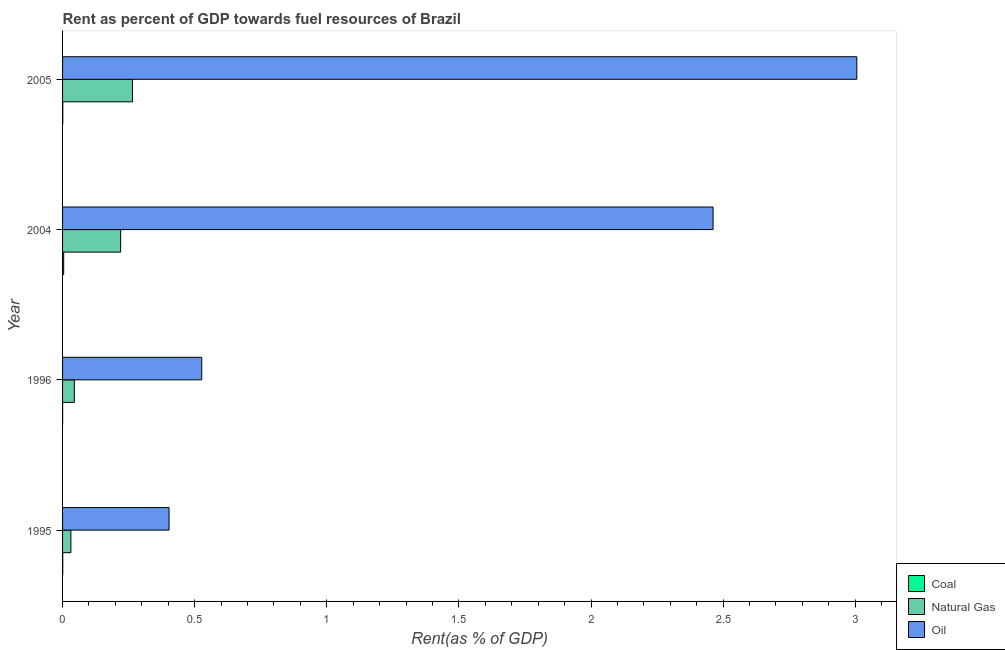Are the number of bars per tick equal to the number of legend labels?
Offer a very short reply. Yes. Are the number of bars on each tick of the Y-axis equal?
Keep it short and to the point. Yes. How many bars are there on the 2nd tick from the top?
Keep it short and to the point. 3. How many bars are there on the 2nd tick from the bottom?
Give a very brief answer. 3. What is the label of the 2nd group of bars from the top?
Offer a terse response. 2004. In how many cases, is the number of bars for a given year not equal to the number of legend labels?
Give a very brief answer. 0. What is the rent towards oil in 1995?
Offer a very short reply. 0.4. Across all years, what is the maximum rent towards natural gas?
Provide a short and direct response. 0.26. Across all years, what is the minimum rent towards coal?
Offer a terse response. 0. What is the total rent towards natural gas in the graph?
Offer a very short reply. 0.56. What is the difference between the rent towards oil in 1995 and that in 2005?
Your answer should be compact. -2.6. What is the difference between the rent towards oil in 1996 and the rent towards coal in 2005?
Provide a succinct answer. 0.53. What is the average rent towards natural gas per year?
Offer a very short reply. 0.14. In the year 1996, what is the difference between the rent towards natural gas and rent towards coal?
Your response must be concise. 0.04. What is the ratio of the rent towards coal in 1996 to that in 2004?
Keep it short and to the point. 0.06. Is the rent towards coal in 2004 less than that in 2005?
Ensure brevity in your answer.  No. What is the difference between the highest and the second highest rent towards coal?
Your answer should be compact. 0. Is the sum of the rent towards oil in 1995 and 1996 greater than the maximum rent towards natural gas across all years?
Provide a short and direct response. Yes. What does the 2nd bar from the top in 1995 represents?
Your response must be concise. Natural Gas. What does the 3rd bar from the bottom in 2004 represents?
Give a very brief answer. Oil. How many bars are there?
Your answer should be very brief. 12. Are all the bars in the graph horizontal?
Offer a very short reply. Yes. How many years are there in the graph?
Offer a very short reply. 4. What is the difference between two consecutive major ticks on the X-axis?
Offer a terse response. 0.5. Does the graph contain grids?
Give a very brief answer. No. Where does the legend appear in the graph?
Provide a succinct answer. Bottom right. How many legend labels are there?
Ensure brevity in your answer.  3. How are the legend labels stacked?
Provide a succinct answer. Vertical. What is the title of the graph?
Keep it short and to the point. Rent as percent of GDP towards fuel resources of Brazil. What is the label or title of the X-axis?
Ensure brevity in your answer.  Rent(as % of GDP). What is the Rent(as % of GDP) in Coal in 1995?
Provide a succinct answer. 0. What is the Rent(as % of GDP) of Natural Gas in 1995?
Keep it short and to the point. 0.03. What is the Rent(as % of GDP) of Oil in 1995?
Your answer should be very brief. 0.4. What is the Rent(as % of GDP) in Coal in 1996?
Offer a terse response. 0. What is the Rent(as % of GDP) in Natural Gas in 1996?
Offer a very short reply. 0.04. What is the Rent(as % of GDP) of Oil in 1996?
Your answer should be compact. 0.53. What is the Rent(as % of GDP) in Coal in 2004?
Keep it short and to the point. 0. What is the Rent(as % of GDP) in Natural Gas in 2004?
Your response must be concise. 0.22. What is the Rent(as % of GDP) of Oil in 2004?
Offer a very short reply. 2.46. What is the Rent(as % of GDP) in Coal in 2005?
Give a very brief answer. 0. What is the Rent(as % of GDP) in Natural Gas in 2005?
Your response must be concise. 0.26. What is the Rent(as % of GDP) of Oil in 2005?
Provide a short and direct response. 3.01. Across all years, what is the maximum Rent(as % of GDP) of Coal?
Make the answer very short. 0. Across all years, what is the maximum Rent(as % of GDP) of Natural Gas?
Offer a terse response. 0.26. Across all years, what is the maximum Rent(as % of GDP) in Oil?
Ensure brevity in your answer.  3.01. Across all years, what is the minimum Rent(as % of GDP) in Coal?
Give a very brief answer. 0. Across all years, what is the minimum Rent(as % of GDP) in Natural Gas?
Your answer should be very brief. 0.03. Across all years, what is the minimum Rent(as % of GDP) of Oil?
Give a very brief answer. 0.4. What is the total Rent(as % of GDP) in Coal in the graph?
Offer a terse response. 0.01. What is the total Rent(as % of GDP) of Natural Gas in the graph?
Offer a very short reply. 0.56. What is the total Rent(as % of GDP) of Oil in the graph?
Give a very brief answer. 6.4. What is the difference between the Rent(as % of GDP) in Natural Gas in 1995 and that in 1996?
Give a very brief answer. -0.01. What is the difference between the Rent(as % of GDP) in Oil in 1995 and that in 1996?
Provide a short and direct response. -0.12. What is the difference between the Rent(as % of GDP) of Coal in 1995 and that in 2004?
Your response must be concise. -0. What is the difference between the Rent(as % of GDP) of Natural Gas in 1995 and that in 2004?
Your answer should be compact. -0.19. What is the difference between the Rent(as % of GDP) in Oil in 1995 and that in 2004?
Your answer should be compact. -2.06. What is the difference between the Rent(as % of GDP) of Coal in 1995 and that in 2005?
Provide a succinct answer. -0. What is the difference between the Rent(as % of GDP) in Natural Gas in 1995 and that in 2005?
Provide a short and direct response. -0.23. What is the difference between the Rent(as % of GDP) in Oil in 1995 and that in 2005?
Keep it short and to the point. -2.6. What is the difference between the Rent(as % of GDP) of Coal in 1996 and that in 2004?
Keep it short and to the point. -0. What is the difference between the Rent(as % of GDP) of Natural Gas in 1996 and that in 2004?
Ensure brevity in your answer.  -0.18. What is the difference between the Rent(as % of GDP) in Oil in 1996 and that in 2004?
Your answer should be very brief. -1.94. What is the difference between the Rent(as % of GDP) of Coal in 1996 and that in 2005?
Provide a short and direct response. -0. What is the difference between the Rent(as % of GDP) in Natural Gas in 1996 and that in 2005?
Provide a short and direct response. -0.22. What is the difference between the Rent(as % of GDP) of Oil in 1996 and that in 2005?
Your answer should be compact. -2.48. What is the difference between the Rent(as % of GDP) in Coal in 2004 and that in 2005?
Your answer should be compact. 0. What is the difference between the Rent(as % of GDP) of Natural Gas in 2004 and that in 2005?
Give a very brief answer. -0.04. What is the difference between the Rent(as % of GDP) of Oil in 2004 and that in 2005?
Offer a terse response. -0.54. What is the difference between the Rent(as % of GDP) of Coal in 1995 and the Rent(as % of GDP) of Natural Gas in 1996?
Offer a very short reply. -0.04. What is the difference between the Rent(as % of GDP) in Coal in 1995 and the Rent(as % of GDP) in Oil in 1996?
Provide a short and direct response. -0.53. What is the difference between the Rent(as % of GDP) of Natural Gas in 1995 and the Rent(as % of GDP) of Oil in 1996?
Make the answer very short. -0.5. What is the difference between the Rent(as % of GDP) in Coal in 1995 and the Rent(as % of GDP) in Natural Gas in 2004?
Your answer should be compact. -0.22. What is the difference between the Rent(as % of GDP) in Coal in 1995 and the Rent(as % of GDP) in Oil in 2004?
Ensure brevity in your answer.  -2.46. What is the difference between the Rent(as % of GDP) of Natural Gas in 1995 and the Rent(as % of GDP) of Oil in 2004?
Give a very brief answer. -2.43. What is the difference between the Rent(as % of GDP) of Coal in 1995 and the Rent(as % of GDP) of Natural Gas in 2005?
Your answer should be very brief. -0.26. What is the difference between the Rent(as % of GDP) of Coal in 1995 and the Rent(as % of GDP) of Oil in 2005?
Your answer should be very brief. -3.01. What is the difference between the Rent(as % of GDP) of Natural Gas in 1995 and the Rent(as % of GDP) of Oil in 2005?
Provide a short and direct response. -2.97. What is the difference between the Rent(as % of GDP) of Coal in 1996 and the Rent(as % of GDP) of Natural Gas in 2004?
Provide a succinct answer. -0.22. What is the difference between the Rent(as % of GDP) in Coal in 1996 and the Rent(as % of GDP) in Oil in 2004?
Give a very brief answer. -2.46. What is the difference between the Rent(as % of GDP) of Natural Gas in 1996 and the Rent(as % of GDP) of Oil in 2004?
Your answer should be compact. -2.42. What is the difference between the Rent(as % of GDP) of Coal in 1996 and the Rent(as % of GDP) of Natural Gas in 2005?
Your response must be concise. -0.26. What is the difference between the Rent(as % of GDP) in Coal in 1996 and the Rent(as % of GDP) in Oil in 2005?
Ensure brevity in your answer.  -3.01. What is the difference between the Rent(as % of GDP) of Natural Gas in 1996 and the Rent(as % of GDP) of Oil in 2005?
Make the answer very short. -2.96. What is the difference between the Rent(as % of GDP) in Coal in 2004 and the Rent(as % of GDP) in Natural Gas in 2005?
Keep it short and to the point. -0.26. What is the difference between the Rent(as % of GDP) of Coal in 2004 and the Rent(as % of GDP) of Oil in 2005?
Provide a succinct answer. -3. What is the difference between the Rent(as % of GDP) in Natural Gas in 2004 and the Rent(as % of GDP) in Oil in 2005?
Your answer should be very brief. -2.79. What is the average Rent(as % of GDP) of Coal per year?
Your answer should be compact. 0. What is the average Rent(as % of GDP) in Natural Gas per year?
Your answer should be very brief. 0.14. What is the average Rent(as % of GDP) of Oil per year?
Provide a short and direct response. 1.6. In the year 1995, what is the difference between the Rent(as % of GDP) of Coal and Rent(as % of GDP) of Natural Gas?
Ensure brevity in your answer.  -0.03. In the year 1995, what is the difference between the Rent(as % of GDP) of Coal and Rent(as % of GDP) of Oil?
Ensure brevity in your answer.  -0.4. In the year 1995, what is the difference between the Rent(as % of GDP) of Natural Gas and Rent(as % of GDP) of Oil?
Your answer should be very brief. -0.37. In the year 1996, what is the difference between the Rent(as % of GDP) of Coal and Rent(as % of GDP) of Natural Gas?
Make the answer very short. -0.04. In the year 1996, what is the difference between the Rent(as % of GDP) of Coal and Rent(as % of GDP) of Oil?
Provide a short and direct response. -0.53. In the year 1996, what is the difference between the Rent(as % of GDP) in Natural Gas and Rent(as % of GDP) in Oil?
Give a very brief answer. -0.48. In the year 2004, what is the difference between the Rent(as % of GDP) in Coal and Rent(as % of GDP) in Natural Gas?
Provide a succinct answer. -0.22. In the year 2004, what is the difference between the Rent(as % of GDP) in Coal and Rent(as % of GDP) in Oil?
Offer a very short reply. -2.46. In the year 2004, what is the difference between the Rent(as % of GDP) in Natural Gas and Rent(as % of GDP) in Oil?
Your answer should be compact. -2.24. In the year 2005, what is the difference between the Rent(as % of GDP) of Coal and Rent(as % of GDP) of Natural Gas?
Offer a very short reply. -0.26. In the year 2005, what is the difference between the Rent(as % of GDP) of Coal and Rent(as % of GDP) of Oil?
Your answer should be very brief. -3.01. In the year 2005, what is the difference between the Rent(as % of GDP) of Natural Gas and Rent(as % of GDP) of Oil?
Your answer should be compact. -2.74. What is the ratio of the Rent(as % of GDP) of Coal in 1995 to that in 1996?
Ensure brevity in your answer.  2.61. What is the ratio of the Rent(as % of GDP) in Natural Gas in 1995 to that in 1996?
Keep it short and to the point. 0.71. What is the ratio of the Rent(as % of GDP) of Oil in 1995 to that in 1996?
Offer a terse response. 0.77. What is the ratio of the Rent(as % of GDP) in Coal in 1995 to that in 2004?
Your answer should be compact. 0.15. What is the ratio of the Rent(as % of GDP) in Natural Gas in 1995 to that in 2004?
Offer a terse response. 0.14. What is the ratio of the Rent(as % of GDP) in Oil in 1995 to that in 2004?
Offer a very short reply. 0.16. What is the ratio of the Rent(as % of GDP) of Coal in 1995 to that in 2005?
Your answer should be compact. 0.73. What is the ratio of the Rent(as % of GDP) in Natural Gas in 1995 to that in 2005?
Give a very brief answer. 0.12. What is the ratio of the Rent(as % of GDP) in Oil in 1995 to that in 2005?
Offer a very short reply. 0.13. What is the ratio of the Rent(as % of GDP) of Coal in 1996 to that in 2004?
Ensure brevity in your answer.  0.06. What is the ratio of the Rent(as % of GDP) of Natural Gas in 1996 to that in 2004?
Offer a very short reply. 0.2. What is the ratio of the Rent(as % of GDP) in Oil in 1996 to that in 2004?
Your answer should be compact. 0.21. What is the ratio of the Rent(as % of GDP) of Coal in 1996 to that in 2005?
Your response must be concise. 0.28. What is the ratio of the Rent(as % of GDP) of Natural Gas in 1996 to that in 2005?
Provide a succinct answer. 0.17. What is the ratio of the Rent(as % of GDP) of Oil in 1996 to that in 2005?
Provide a succinct answer. 0.18. What is the ratio of the Rent(as % of GDP) in Coal in 2004 to that in 2005?
Your answer should be compact. 4.93. What is the ratio of the Rent(as % of GDP) of Natural Gas in 2004 to that in 2005?
Your answer should be very brief. 0.83. What is the ratio of the Rent(as % of GDP) in Oil in 2004 to that in 2005?
Offer a terse response. 0.82. What is the difference between the highest and the second highest Rent(as % of GDP) of Coal?
Your answer should be compact. 0. What is the difference between the highest and the second highest Rent(as % of GDP) of Natural Gas?
Keep it short and to the point. 0.04. What is the difference between the highest and the second highest Rent(as % of GDP) in Oil?
Ensure brevity in your answer.  0.54. What is the difference between the highest and the lowest Rent(as % of GDP) in Coal?
Provide a short and direct response. 0. What is the difference between the highest and the lowest Rent(as % of GDP) in Natural Gas?
Your answer should be compact. 0.23. What is the difference between the highest and the lowest Rent(as % of GDP) in Oil?
Your answer should be very brief. 2.6. 